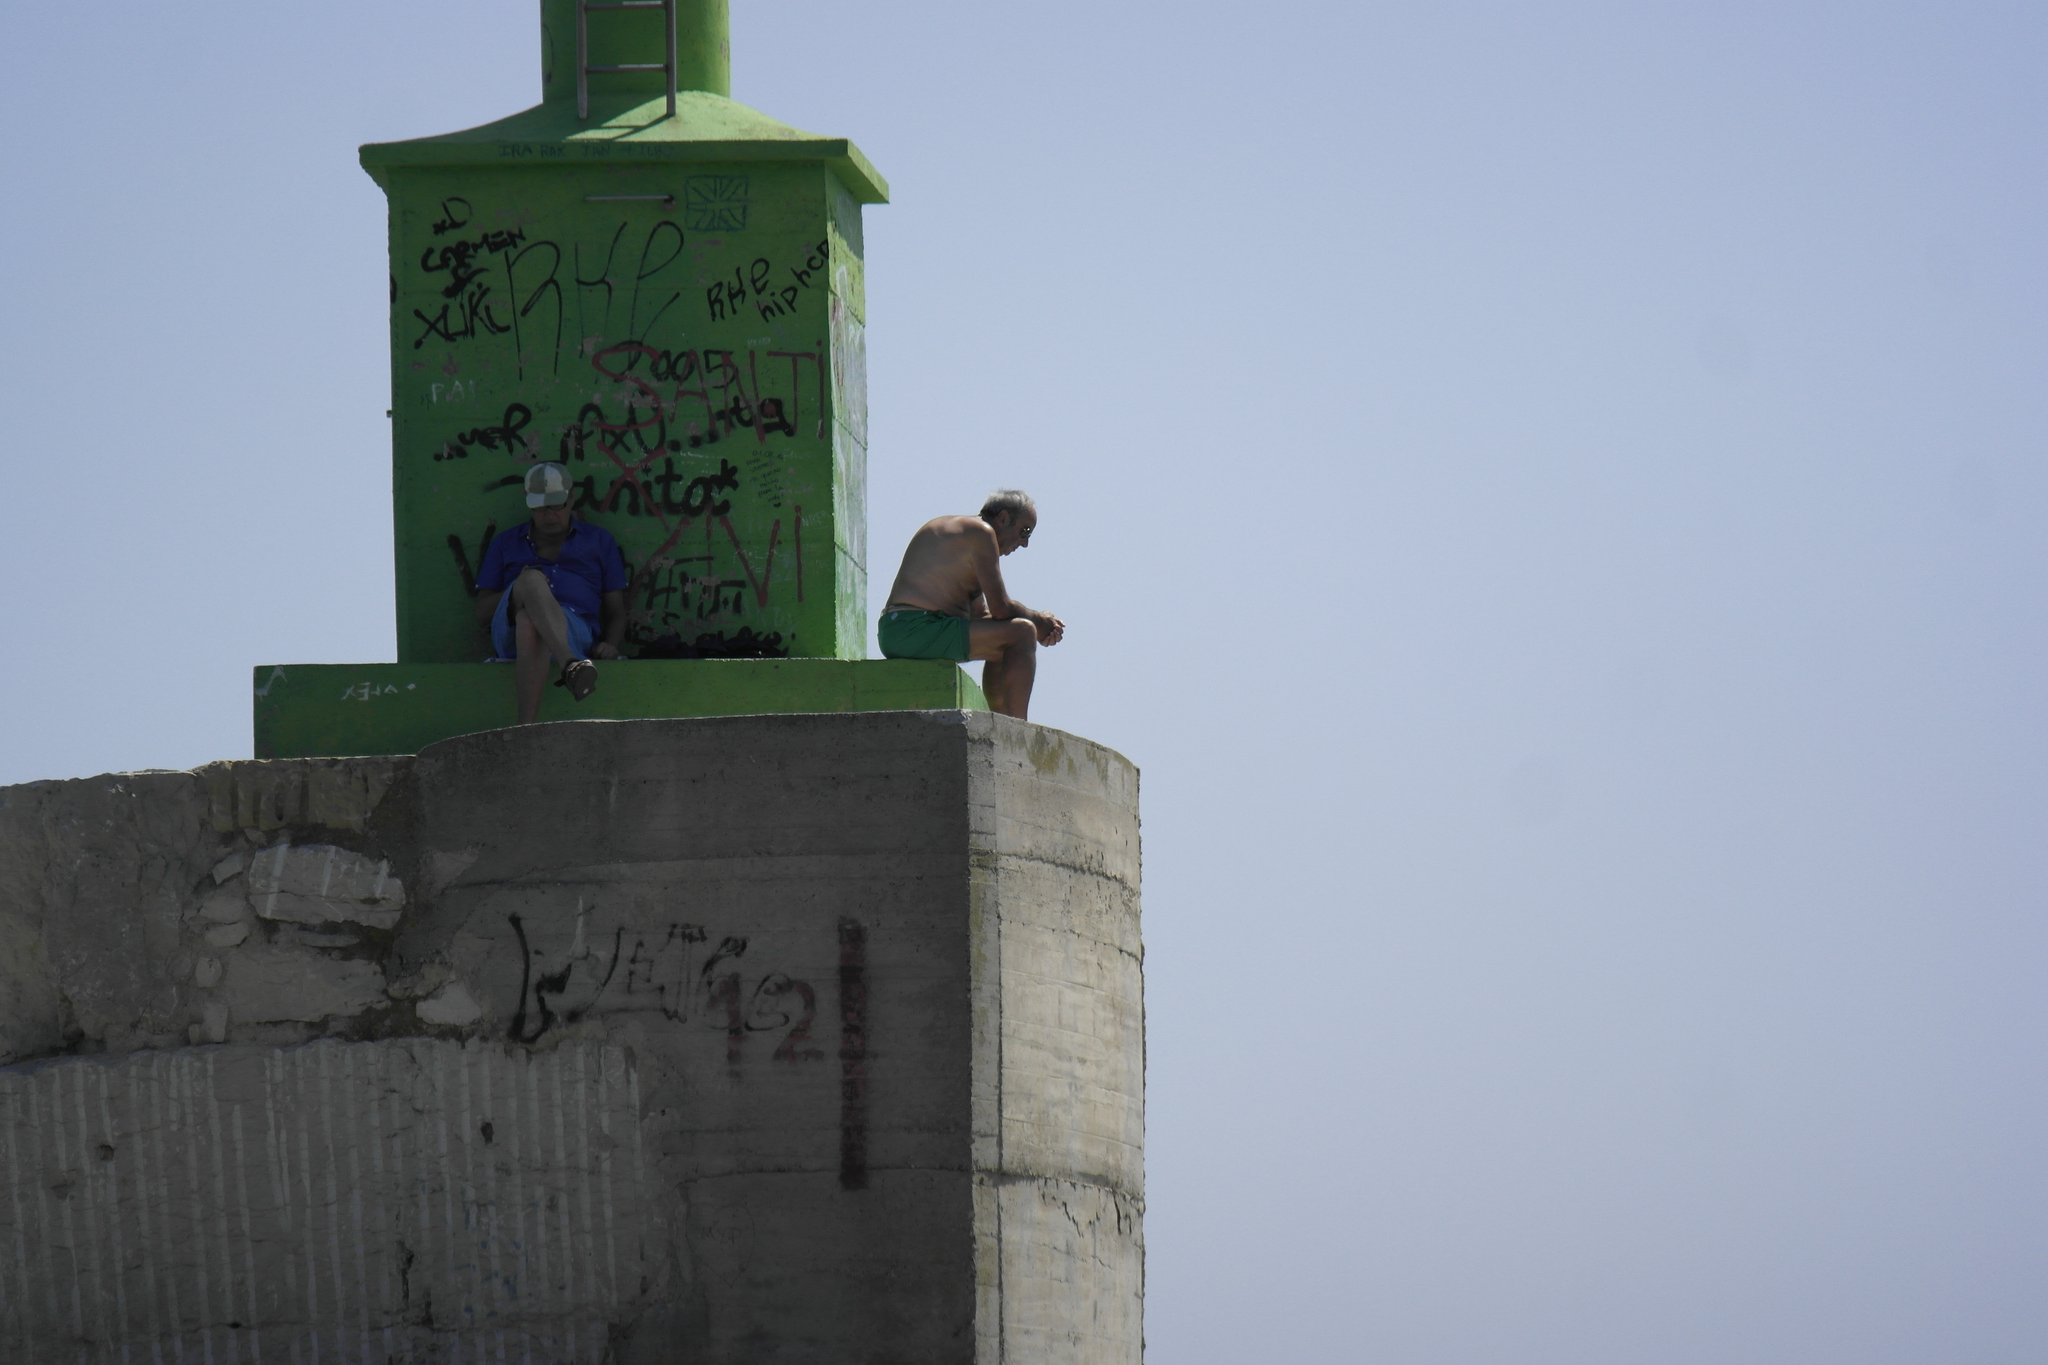Can you describe this image briefly? In this picture, it seems like people on the architecture in the foreground and the sky in the background. 